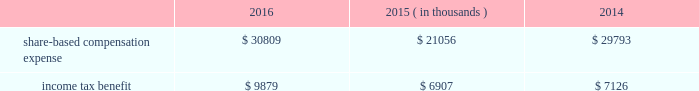2000 non-employee director stock option plan ( the 201cdirector stock option plan 201d ) , and the global payments inc .
2011 incentive plan ( the 201c2011 plan 201d ) ( collectively , the 201cplans 201d ) .
We made no further grants under the 2000 plan after the 2005 plan was effective , and the director stock option plan expired by its terms on february 1 , 2011 .
We will make no future grants under the 2000 plan , the 2005 plan or the director stock option plan .
The 2011 plan permits grants of equity to employees , officers , directors and consultants .
A total of 14.0 million shares of our common stock was reserved and made available for issuance pursuant to awards granted under the 2011 plan .
The table summarizes share-based compensation expense and the related income tax benefit recognized for our share-based awards and stock options ( in thousands ) : 2016 2015 2014 ( in thousands ) .
We grant various share-based awards pursuant to the plans under what we refer to as our 201clong-term incentive plan . 201d the awards are held in escrow and released upon the grantee 2019s satisfaction of conditions of the award certificate .
Restricted stock restricted stock awards vest over a period of time , provided , however , that if the grantee is not employed by us on the vesting date , the shares are forfeited .
Restricted shares cannot be sold or transferred until they have vested .
Restricted stock granted before fiscal 2015 vests in equal installments on each of the first four anniversaries of the grant date .
Restricted stock granted during fiscal 2015 and thereafter either vest in equal installments on each of the first three anniversaries of the grant date or cliff vest at the end of a three-year service period .
The grant date fair value of restricted stock , which is based on the quoted market value of our common stock at the closing of the award date , is recognized as share-based compensation expense on a straight-line basis over the vesting period .
Performance units certain of our executives have been granted performance units under our long-term incentive plan .
Performance units are performance-based restricted stock units that , after a performance period , convert into common shares , which may be restricted .
The number of shares is dependent upon the achievement of certain performance measures during the performance period .
The target number of performance units and any market-based performance measures ( 201cat threshold , 201d 201ctarget , 201d and 201cmaximum 201d ) are set by the compensation committee of our board of directors .
Performance units are converted only after the compensation committee certifies performance based on pre-established goals .
The performance units granted to certain executives in fiscal 2014 were based on a one-year performance period .
After the compensation committee certified the performance results , 25% ( 25 % ) of the performance units converted to unrestricted shares .
The remaining 75% ( 75 % ) converted to restricted shares that vest in equal installments on each of the first three anniversaries of the conversion date .
The performance units granted to certain executives during fiscal 2015 and fiscal 2016 were based on a three-year performance period .
After the compensation committee certifies the performance results for the three-year period , performance units earned will convert into unrestricted common stock .
The compensation committee may set a range of possible performance-based outcomes for performance units .
Depending on the achievement of the performance measures , the grantee may earn up to 200% ( 200 % ) of the target number of shares .
For awards with only performance conditions , we recognize compensation expense on a straight-line basis over the performance period using the grant date fair value of the award , which is based on the number of shares expected to be earned according to the level of achievement of performance goals .
If the number of shares expected to be earned were to change at any time during the performance period , we would make a cumulative adjustment to share-based compensation expense based on the revised number of shares expected to be earned .
Global payments inc .
| 2016 form 10-k annual report 2013 83 .
How much percent did the income tax benefit increase from 2014 to 2016? 
Rationale: the tax benefit increased 38.6% , one can find this by subtracting 2016 by 2014 tax benefits . then taking the answer and dividing it by 2014 tax benefits .
Computations: ((9879 - 7126) / 7126)
Answer: 0.38633. 